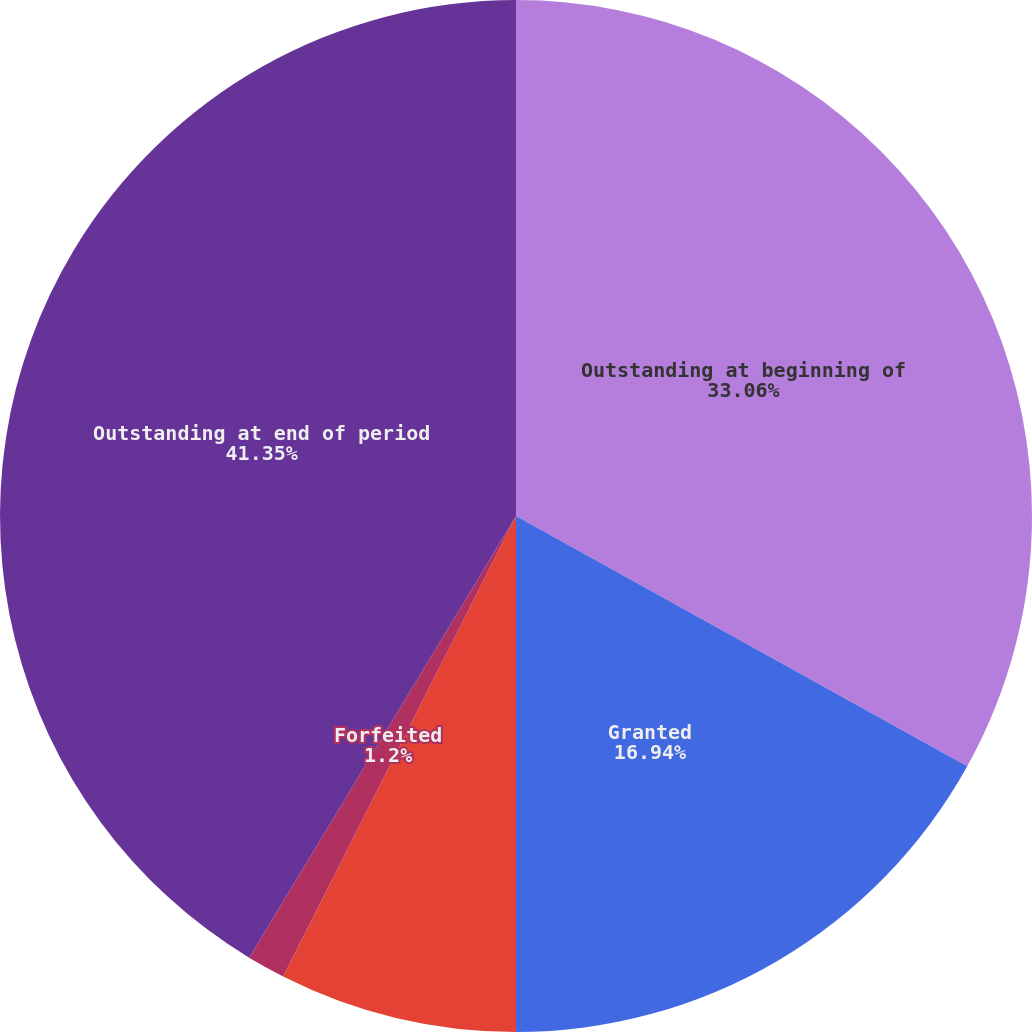Convert chart to OTSL. <chart><loc_0><loc_0><loc_500><loc_500><pie_chart><fcel>Outstanding at beginning of<fcel>Granted<fcel>Vested<fcel>Forfeited<fcel>Outstanding at end of period<nl><fcel>33.06%<fcel>16.94%<fcel>7.45%<fcel>1.2%<fcel>41.35%<nl></chart> 